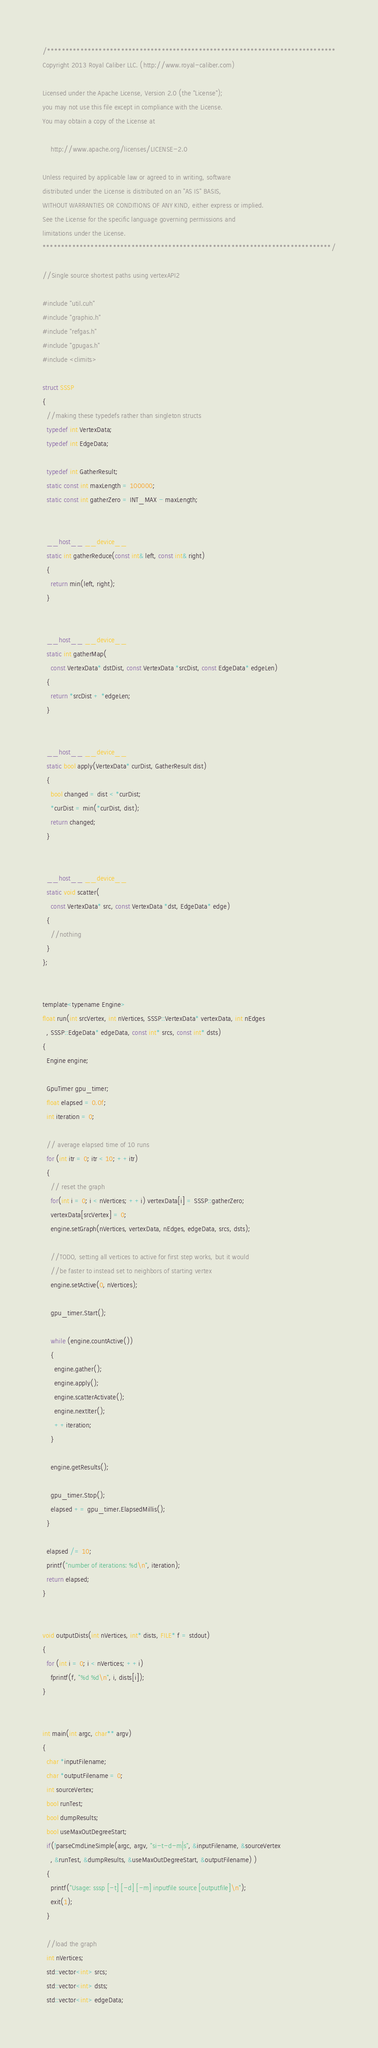Convert code to text. <code><loc_0><loc_0><loc_500><loc_500><_Cuda_>/******************************************************************************
Copyright 2013 Royal Caliber LLC. (http://www.royal-caliber.com)

Licensed under the Apache License, Version 2.0 (the "License");
you may not use this file except in compliance with the License.
You may obtain a copy of the License at

    http://www.apache.org/licenses/LICENSE-2.0

Unless required by applicable law or agreed to in writing, software
distributed under the License is distributed on an "AS IS" BASIS,
WITHOUT WARRANTIES OR CONDITIONS OF ANY KIND, either express or implied.
See the License for the specific language governing permissions and
limitations under the License.
******************************************************************************/

//Single source shortest paths using vertexAPI2

#include "util.cuh"
#include "graphio.h"
#include "refgas.h"
#include "gpugas.h"
#include <climits>

struct SSSP
{
  //making these typedefs rather than singleton structs
  typedef int VertexData;
  typedef int EdgeData;

  typedef int GatherResult;
  static const int maxLength = 100000;
  static const int gatherZero = INT_MAX - maxLength;


  __host__ __device__
  static int gatherReduce(const int& left, const int& right)
  {
    return min(left, right);
  }


  __host__ __device__
  static int gatherMap(
    const VertexData* dstDist, const VertexData *srcDist, const EdgeData* edgeLen)
  {
    return *srcDist + *edgeLen;
  }


  __host__ __device__
  static bool apply(VertexData* curDist, GatherResult dist)
  {
    bool changed = dist < *curDist;
    *curDist = min(*curDist, dist);
    return changed;
  }


  __host__ __device__
  static void scatter(
    const VertexData* src, const VertexData *dst, EdgeData* edge)
  {
    //nothing
  }
};


template<typename Engine>
float run(int srcVertex, int nVertices, SSSP::VertexData* vertexData, int nEdges
  , SSSP::EdgeData* edgeData, const int* srcs, const int* dsts)
{
  Engine engine;

  GpuTimer gpu_timer;
  float elapsed = 0.0f;
  int iteration = 0;

  // average elapsed time of 10 runs
  for (int itr = 0; itr < 10; ++itr)
  {
    // reset the graph
    for(int i = 0; i < nVertices; ++i) vertexData[i] = SSSP::gatherZero;
    vertexData[srcVertex] = 0;
    engine.setGraph(nVertices, vertexData, nEdges, edgeData, srcs, dsts);

    //TODO, setting all vertices to active for first step works, but it would
    //be faster to instead set to neighbors of starting vertex
    engine.setActive(0, nVertices);

    gpu_timer.Start();

    while (engine.countActive())
    {
      engine.gather();
      engine.apply();
      engine.scatterActivate();
      engine.nextIter();
      ++iteration;
    }

    engine.getResults();

    gpu_timer.Stop();
    elapsed += gpu_timer.ElapsedMillis();
  }

  elapsed /= 10;
  printf("number of iterations: %d\n", iteration);
  return elapsed;
}


void outputDists(int nVertices, int* dists, FILE* f = stdout)
{
  for (int i = 0; i < nVertices; ++i)
    fprintf(f, "%d %d\n", i, dists[i]);
}


int main(int argc, char** argv)
{
  char *inputFilename;
  char *outputFilename = 0;
  int sourceVertex;
  bool runTest;
  bool dumpResults;
  bool useMaxOutDegreeStart;
  if(!parseCmdLineSimple(argc, argv, "si-t-d-m|s", &inputFilename, &sourceVertex
    , &runTest, &dumpResults, &useMaxOutDegreeStart, &outputFilename) )
  {
    printf("Usage: sssp [-t] [-d] [-m] inputfile source [outputfile]\n");
    exit(1);
  }

  //load the graph
  int nVertices;
  std::vector<int> srcs;
  std::vector<int> dsts;
  std::vector<int> edgeData;</code> 